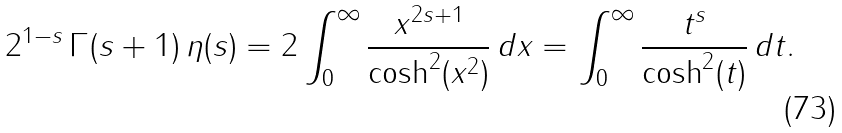<formula> <loc_0><loc_0><loc_500><loc_500>2 ^ { 1 - s } \, \Gamma ( s + 1 ) \, \eta ( s ) = 2 \int _ { 0 } ^ { \infty } { \frac { x ^ { 2 s + 1 } } { \cosh ^ { 2 } ( x ^ { 2 } ) } } \, d x = \int _ { 0 } ^ { \infty } { \frac { t ^ { s } } { \cosh ^ { 2 } ( t ) } } \, d t .</formula> 